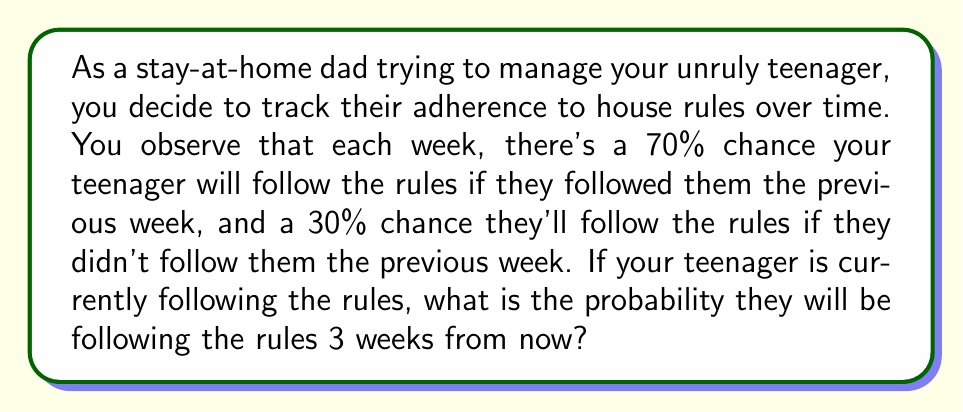Can you solve this math problem? This problem can be solved using Markov chains. Let's break it down step-by-step:

1) First, let's define our states:
   State 0: Not following rules
   State 1: Following rules

2) We can represent the transition probabilities in a matrix:

   $$P = \begin{bmatrix}
   0.7 & 0.3 \\
   0.3 & 0.7
   \end{bmatrix}$$

   Where $P_{ij}$ is the probability of moving from state $i$ to state $j$.

3) The initial state vector is $[0 \quad 1]$ because the teenager is currently following the rules.

4) To find the probability after 3 weeks, we need to multiply the initial state vector by the transition matrix raised to the power of 3:

   $$[0 \quad 1] \cdot P^3$$

5) Let's calculate $P^3$:

   $$P^2 = \begin{bmatrix}
   0.7 & 0.3 \\
   0.3 & 0.7
   \end{bmatrix} \cdot \begin{bmatrix}
   0.7 & 0.3 \\
   0.3 & 0.7
   \end{bmatrix} = \begin{bmatrix}
   0.58 & 0.42 \\
   0.42 & 0.58
   \end{bmatrix}$$

   $$P^3 = P^2 \cdot P = \begin{bmatrix}
   0.58 & 0.42 \\
   0.42 & 0.58
   \end{bmatrix} \cdot \begin{bmatrix}
   0.7 & 0.3 \\
   0.3 & 0.7
   \end{bmatrix} = \begin{bmatrix}
   0.546 & 0.454 \\
   0.454 & 0.546
   \end{bmatrix}$$

6) Now, we multiply the initial state vector by $P^3$:

   $$[0 \quad 1] \cdot \begin{bmatrix}
   0.546 & 0.454 \\
   0.454 & 0.546
   \end{bmatrix} = [0.454 \quad 0.546]$$

7) The second element of this resulting vector, 0.546, represents the probability of being in state 1 (following rules) after 3 weeks.
Answer: The probability that the teenager will be following the rules 3 weeks from now is 0.546 or 54.6%. 